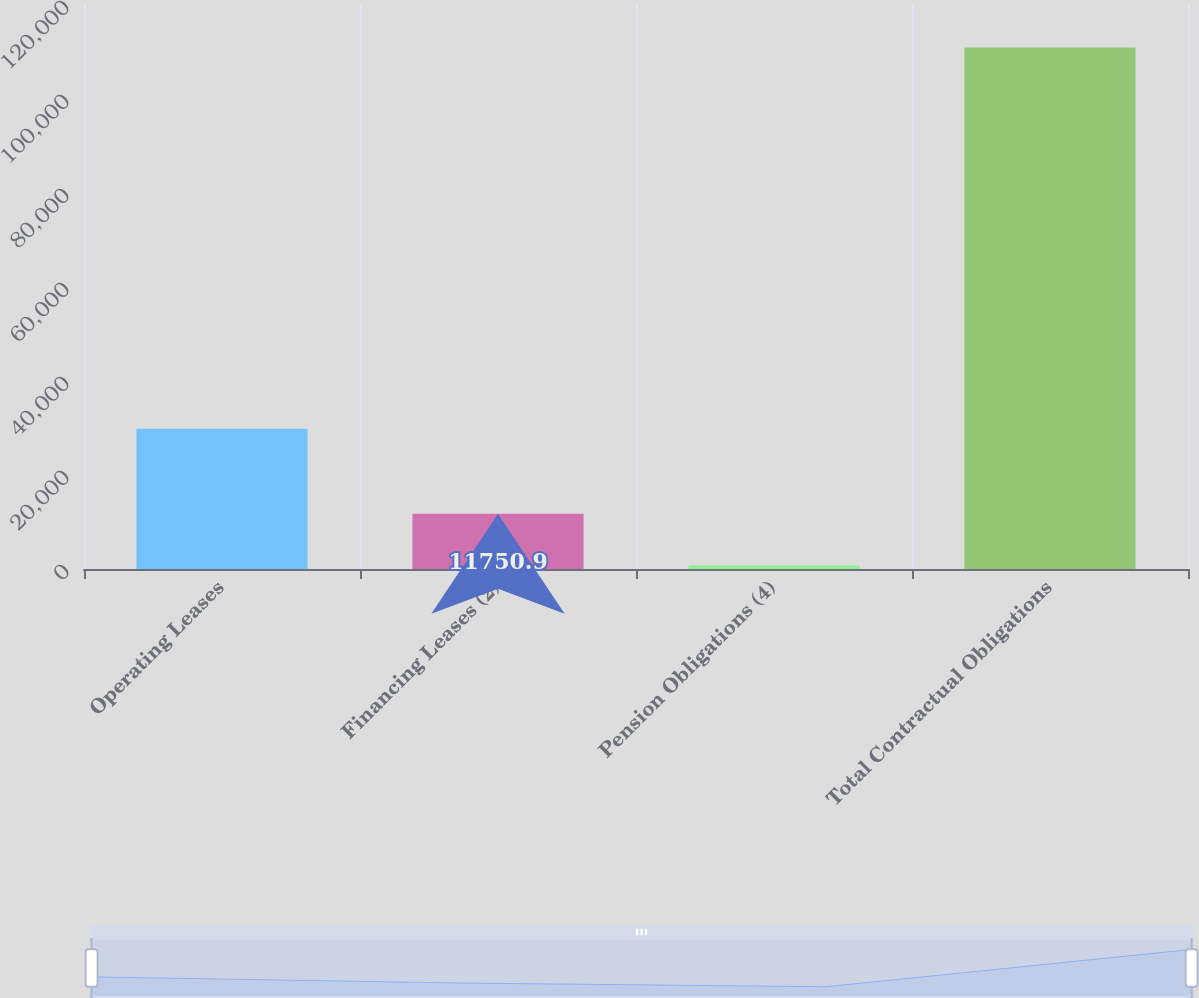Convert chart to OTSL. <chart><loc_0><loc_0><loc_500><loc_500><bar_chart><fcel>Operating Leases<fcel>Financing Leases (2)<fcel>Pension Obligations (4)<fcel>Total Contractual Obligations<nl><fcel>29829<fcel>11750.9<fcel>728<fcel>110957<nl></chart> 